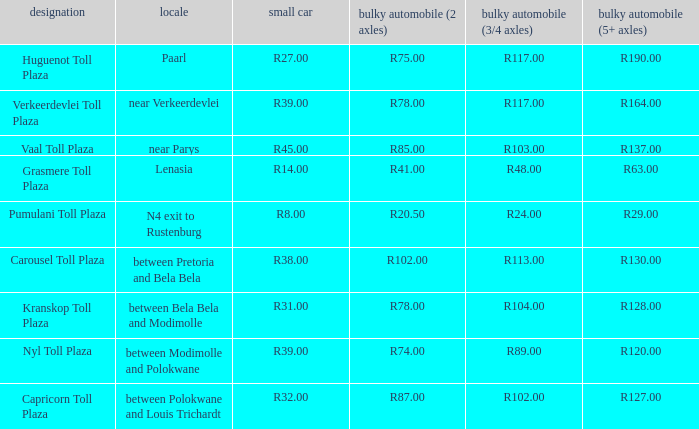What is the toll for light vehicles at the plaza where the toll for heavy vehicles with 2 axles is r87.00? R32.00. 